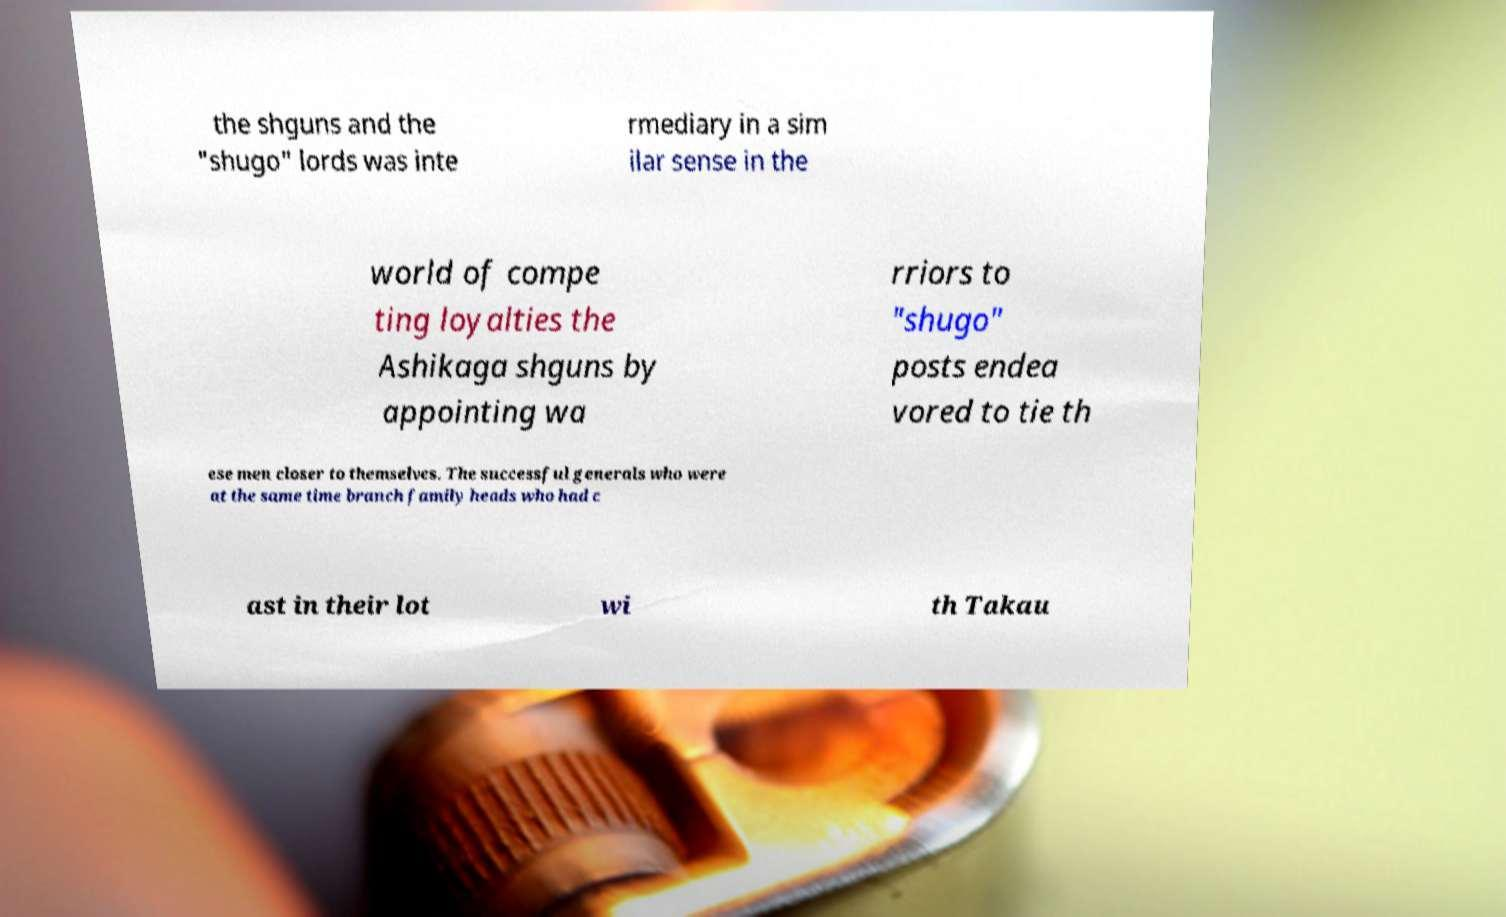For documentation purposes, I need the text within this image transcribed. Could you provide that? the shguns and the "shugo" lords was inte rmediary in a sim ilar sense in the world of compe ting loyalties the Ashikaga shguns by appointing wa rriors to "shugo" posts endea vored to tie th ese men closer to themselves. The successful generals who were at the same time branch family heads who had c ast in their lot wi th Takau 